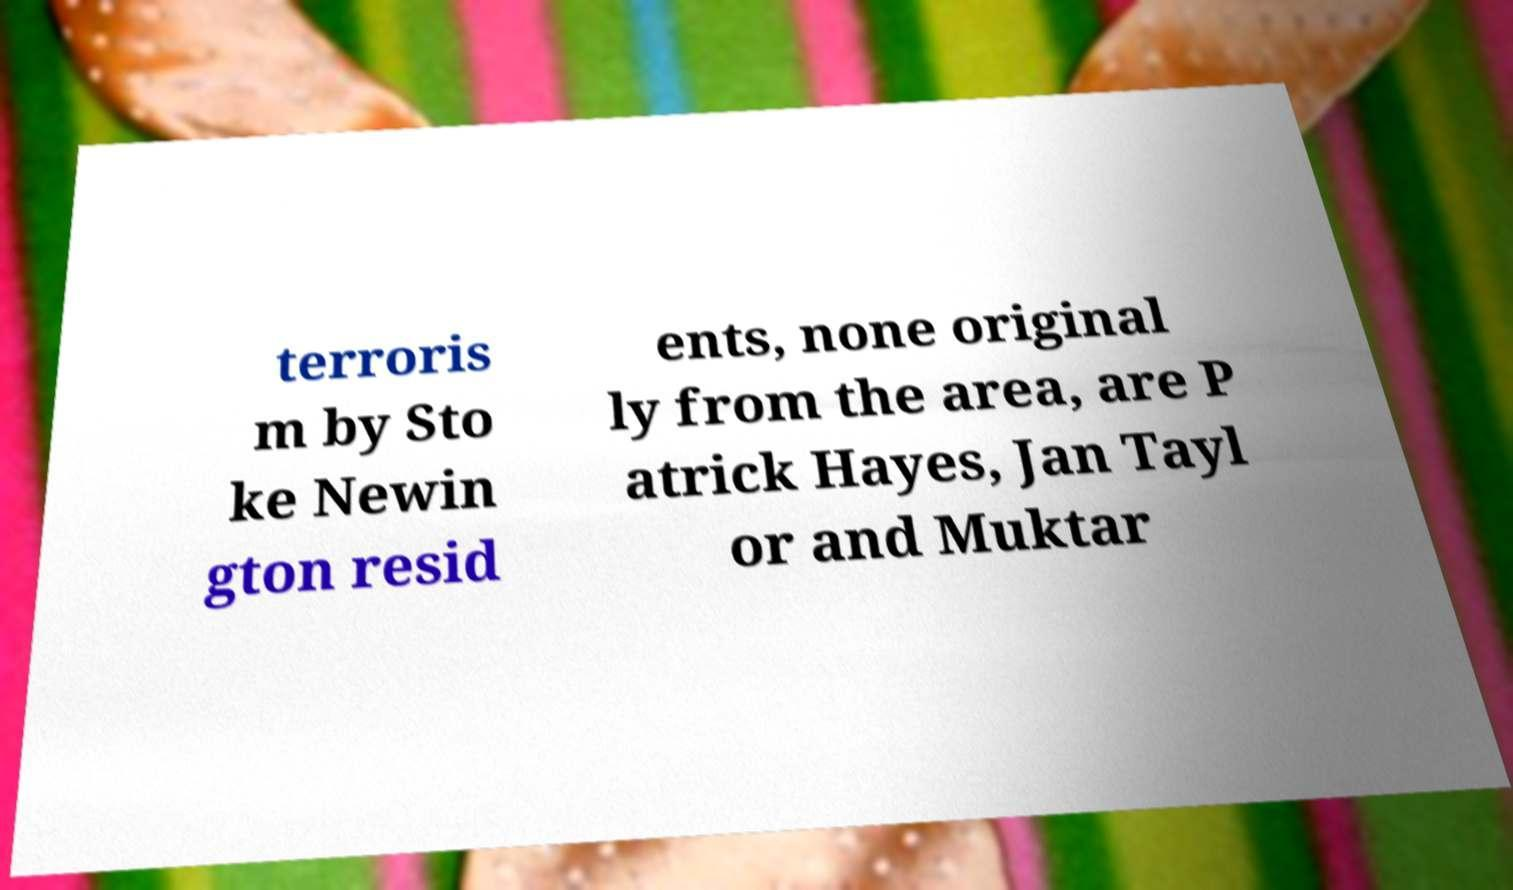I need the written content from this picture converted into text. Can you do that? terroris m by Sto ke Newin gton resid ents, none original ly from the area, are P atrick Hayes, Jan Tayl or and Muktar 